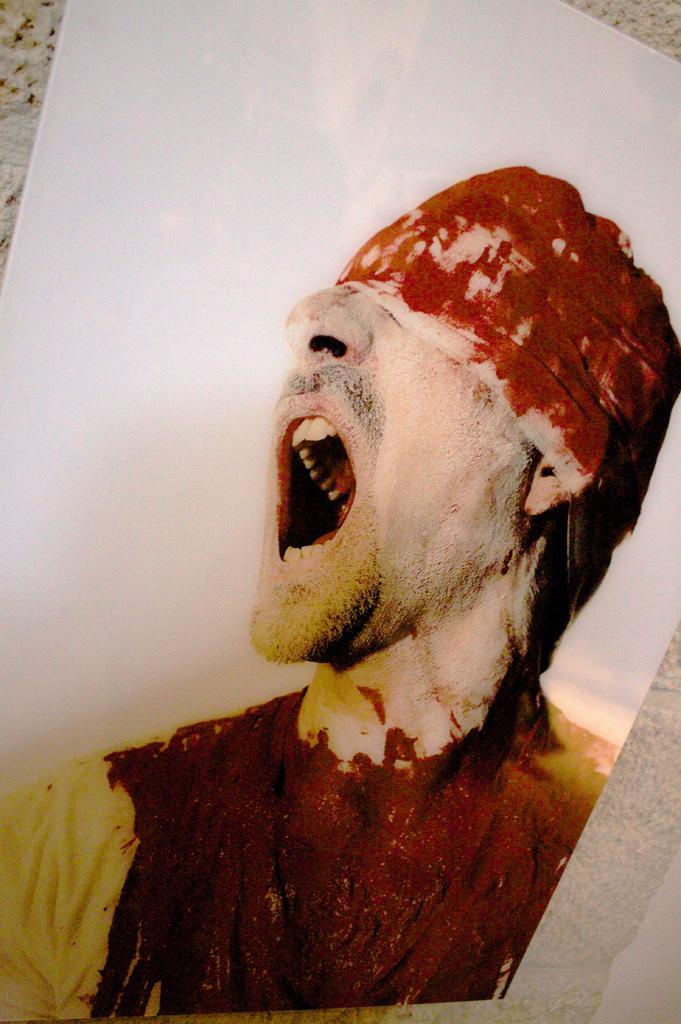How would you summarize this image in a sentence or two? In the image there is a photograph on an injured man with band over his head on the wall. 